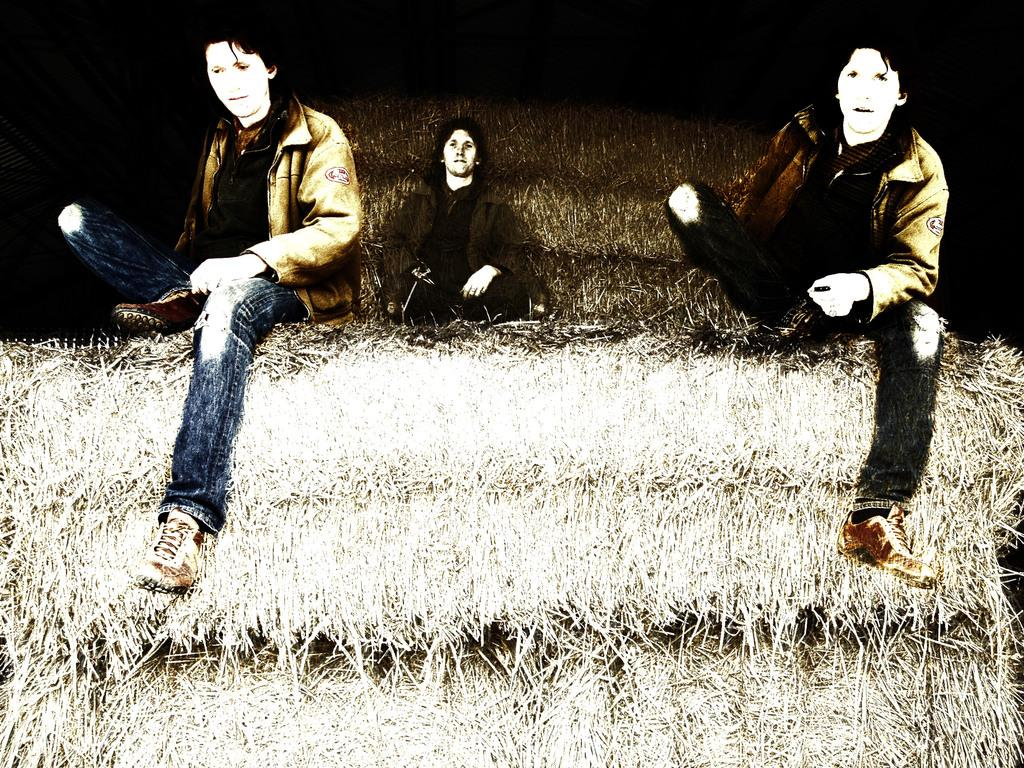How many people are sitting in the image? There are three persons sitting in the image. What is the person on the left wearing? The person on the left is wearing a brown color blazer and blue pants. What can be observed about the background of the image? The background of the image is dark. What type of coastline can be seen in the image? There is no coastline present in the image; it features three persons sitting. How does the person on the right attempt to pull the person in the middle closer? There is no indication in the image of anyone attempting to pull anyone else closer. 